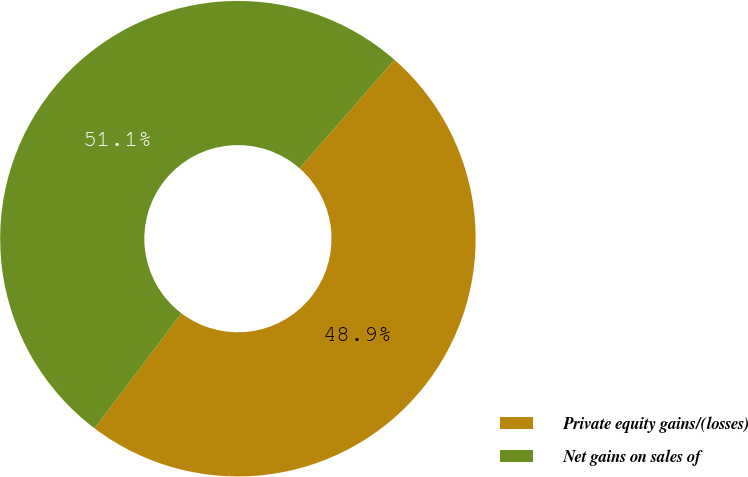Convert chart to OTSL. <chart><loc_0><loc_0><loc_500><loc_500><pie_chart><fcel>Private equity gains/(losses)<fcel>Net gains on sales of<nl><fcel>48.86%<fcel>51.14%<nl></chart> 